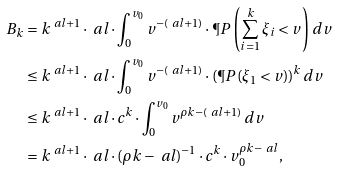Convert formula to latex. <formula><loc_0><loc_0><loc_500><loc_500>B _ { k } & = k ^ { \ a l + 1 } \cdot \ a l \cdot \int _ { 0 } ^ { v _ { 0 } } v ^ { - ( \ a l + 1 ) } \cdot \P P \left ( \sum _ { i = 1 } ^ { k } \xi _ { i } < v \right ) \, d v \\ & \leq k ^ { \ a l + 1 } \cdot \ a l \cdot \int _ { 0 } ^ { v _ { 0 } } v ^ { - ( \ a l + 1 ) } \cdot ( \P P ( \xi _ { 1 } < v ) ) ^ { k } \, d v \\ & \leq k ^ { \ a l + 1 } \cdot \ a l \cdot c ^ { k } \cdot \int _ { 0 } ^ { v _ { 0 } } v ^ { \rho k - ( \ a l + 1 ) } \, d v \\ & = k ^ { \ a l + 1 } \cdot \ a l \cdot ( \rho k - \ a l ) ^ { - 1 } \cdot c ^ { k } \cdot v _ { 0 } ^ { \rho k - \ a l } ,</formula> 